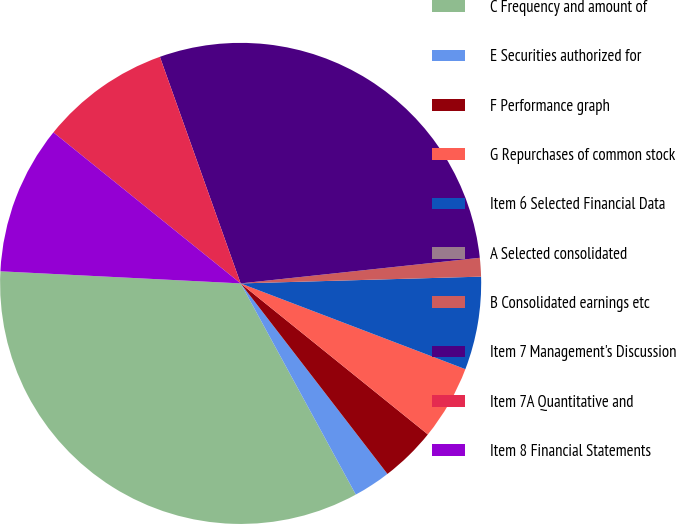<chart> <loc_0><loc_0><loc_500><loc_500><pie_chart><fcel>C Frequency and amount of<fcel>E Securities authorized for<fcel>F Performance graph<fcel>G Repurchases of common stock<fcel>Item 6 Selected Financial Data<fcel>A Selected consolidated<fcel>B Consolidated earnings etc<fcel>Item 7 Management's Discussion<fcel>Item 7A Quantitative and<fcel>Item 8 Financial Statements<nl><fcel>33.75%<fcel>2.5%<fcel>3.75%<fcel>5.0%<fcel>6.25%<fcel>0.0%<fcel>1.25%<fcel>28.75%<fcel>8.75%<fcel>10.0%<nl></chart> 